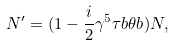Convert formula to latex. <formula><loc_0><loc_0><loc_500><loc_500>N ^ { \prime } = ( 1 - \frac { i } { 2 } \gamma ^ { 5 } { \tau b } { \theta b } ) N ,</formula> 